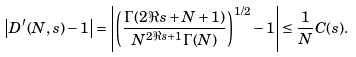Convert formula to latex. <formula><loc_0><loc_0><loc_500><loc_500>\left | D ^ { \prime } ( N , s ) - 1 \right | = \left | \left ( \frac { \Gamma ( 2 \Re { s } + N + 1 ) } { N ^ { 2 \Re { s } + 1 } \Gamma ( N ) } \right ) ^ { 1 / 2 } - 1 \right | \leq \frac { 1 } { N } C ( s ) .</formula> 